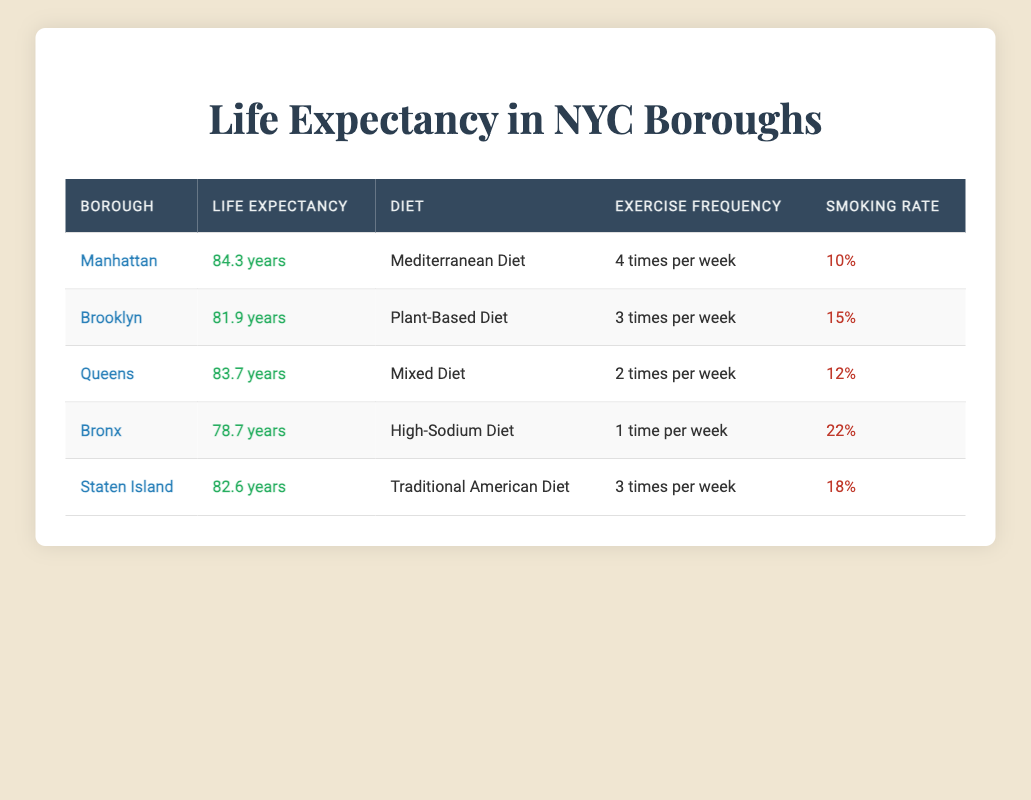What is the average life expectancy in Manhattan? The table shows that the average life expectancy in Manhattan is listed as 84.3 years.
Answer: 84.3 years Which borough has the highest smoking rate? According to the table, the Bronx has the highest smoking rate at 22%.
Answer: Bronx How often do residents in Staten Island exercise? The table indicates that residents in Staten Island exercise 3 times per week.
Answer: 3 times per week What is the total average life expectancy of Brooklyn and Staten Island? For Brooklyn, the average life expectancy is 81.9 years, and for Staten Island, it is 82.6 years. Adding these together gives 81.9 + 82.6 = 164.5 years, which needs to be averaged by dividing by 2, resulting in 164.5/2 = 82.25 years.
Answer: 82.25 years Is the smoking rate in Queens higher than in Brooklyn? The smoking rate in Queens is 12%, while in Brooklyn it is 15%. Therefore, the statement is false.
Answer: No Which diet is associated with the borough that has the lowest life expectancy? The Bronx has the lowest life expectancy at 78.7 years and is associated with a high-sodium diet according to the table.
Answer: High-Sodium Diet If all boroughs except the Bronx had similar smoking rates, what would be the average smoking rate for them? The smoking rates for Brooklyn, Manhattan, Queens, and Staten Island are 15%, 10%, 12%, and 18%, respectively. Adding these gives 15 + 10 + 12 + 18 = 55%. To find the average, we divide by 4, which results in 55/4 = 13.75%.
Answer: 13.75% Are residents in Manhattan exercising more often than those in the Bronx? Residents in Manhattan exercise 4 times per week while those in the Bronx only exercise 1 time per week, making this statement true.
Answer: Yes 